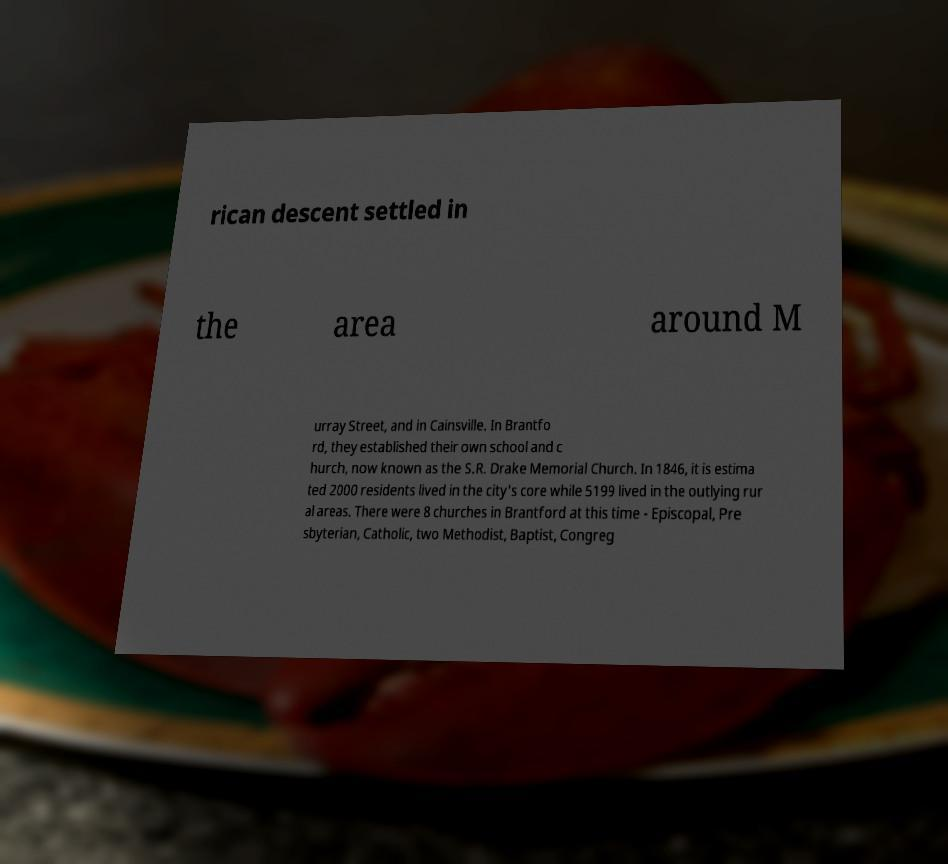Please read and relay the text visible in this image. What does it say? rican descent settled in the area around M urray Street, and in Cainsville. In Brantfo rd, they established their own school and c hurch, now known as the S.R. Drake Memorial Church. In 1846, it is estima ted 2000 residents lived in the city's core while 5199 lived in the outlying rur al areas. There were 8 churches in Brantford at this time - Episcopal, Pre sbyterian, Catholic, two Methodist, Baptist, Congreg 